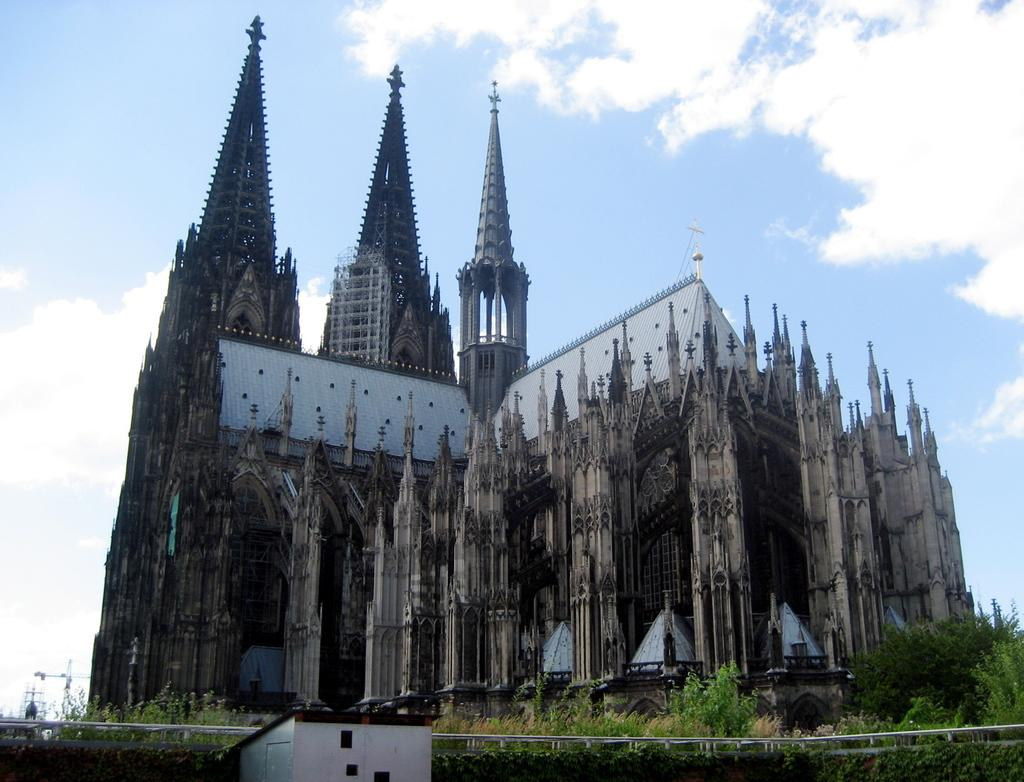What type of structure can be seen in the image? There is a building in the image. What other structures are present in the image? There is a shed and a fence in the image. What type of vegetation is visible in the image? There are trees in the image. What else can be seen in the image? There are poles in the image. What is visible in the sky at the top of the image? There are clouds in the sky at the top of the image. What type of eggnog is being served in the image? There is no eggnog present in the image. What decision is being made by the trees in the image? The trees in the image are not making any decisions, as they are inanimate objects. 